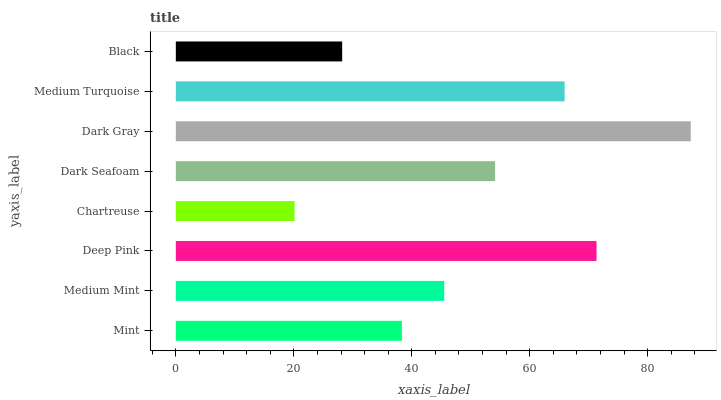Is Chartreuse the minimum?
Answer yes or no. Yes. Is Dark Gray the maximum?
Answer yes or no. Yes. Is Medium Mint the minimum?
Answer yes or no. No. Is Medium Mint the maximum?
Answer yes or no. No. Is Medium Mint greater than Mint?
Answer yes or no. Yes. Is Mint less than Medium Mint?
Answer yes or no. Yes. Is Mint greater than Medium Mint?
Answer yes or no. No. Is Medium Mint less than Mint?
Answer yes or no. No. Is Dark Seafoam the high median?
Answer yes or no. Yes. Is Medium Mint the low median?
Answer yes or no. Yes. Is Medium Mint the high median?
Answer yes or no. No. Is Dark Seafoam the low median?
Answer yes or no. No. 